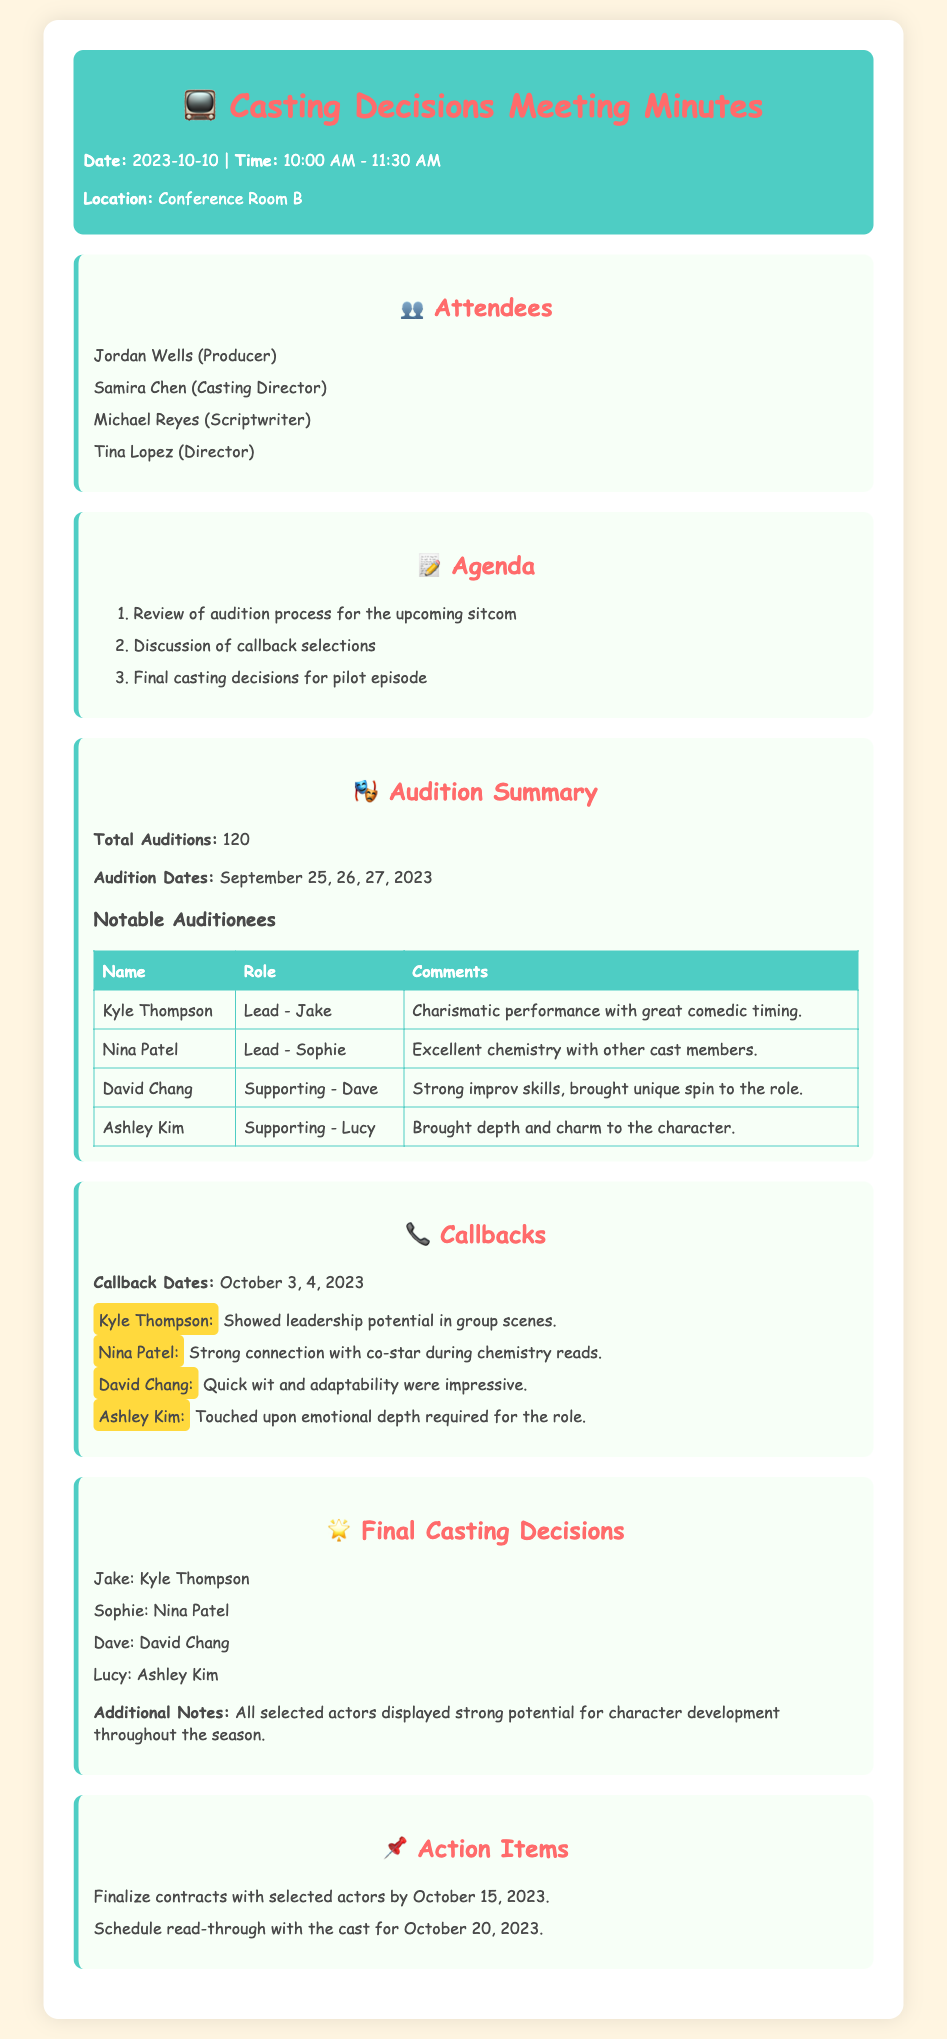what is the date of the meeting? The meeting took place on October 10, 2023, as noted in the header section.
Answer: October 10, 2023 how many total auditions were there? The document states the total number of auditions held for the sitcom is 120.
Answer: 120 who played the character of Jake? The final casting decision indicates Kyle Thompson is cast as Jake.
Answer: Kyle Thompson what were the callback dates? Callback dates for the selected actors are mentioned as October 3 and 4, 2023.
Answer: October 3, 4, 2023 which actor showed leadership potential in group scenes? The document highlights that Kyle Thompson showed leadership potential during callbacks.
Answer: Kyle Thompson what is the role of Nina Patel? The casting decision lists Nina Patel as the actor for the role of Sophie.
Answer: Sophie what is one notable quality of David Chang's audition? The document notes David Chang's strong improv skills during his audition, indicating a unique interpretation of his role.
Answer: Strong improv skills how many attendees were present at the meeting? The attendee list shows there were four individuals present at the meeting.
Answer: Four what is the deadline for finalizing contracts with the selected actors? The action item states the contracts need to be finalized by October 15, 2023.
Answer: October 15, 2023 what is the scheduled date for the read-through with the cast? The action items specify the read-through is scheduled for October 20, 2023.
Answer: October 20, 2023 